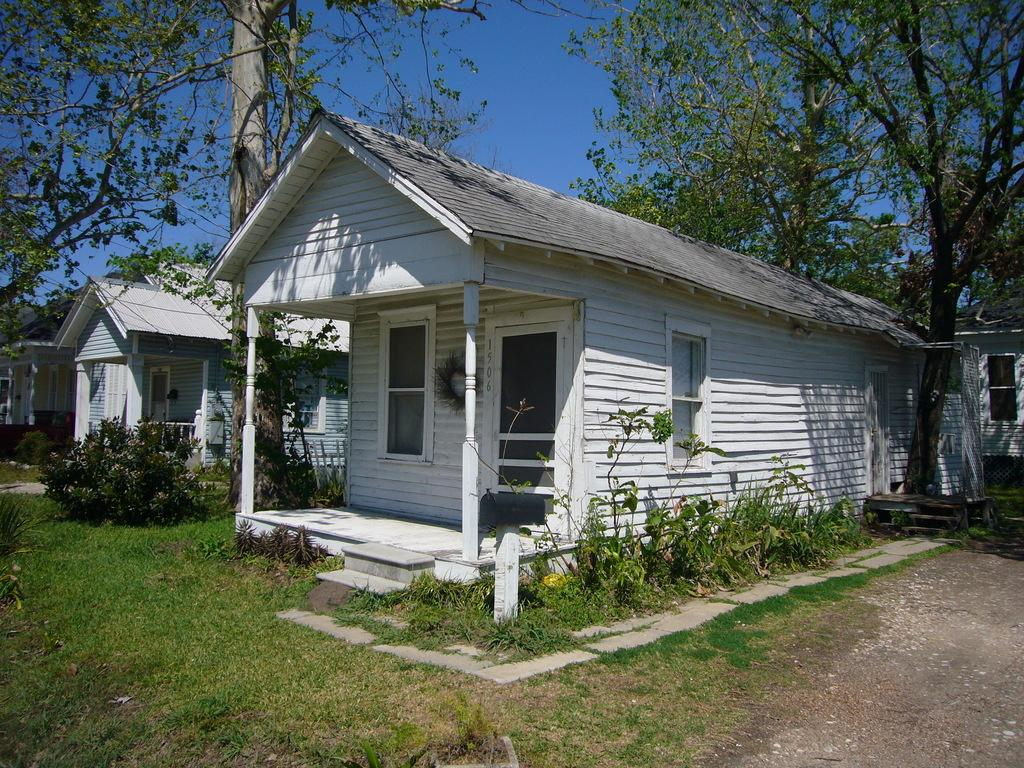How many wooden houses are there in the image? There are three wooden houses in a row in the image. What is the color of the houses? The houses are of white color. What can be seen around the houses? There is some greenery around the houses. What type of vegetation is present beside the houses? There are tall trees beside the houses. What type of club can be seen in the image? There is no club present in the image; it features three white wooden houses with greenery and tall trees around them. 